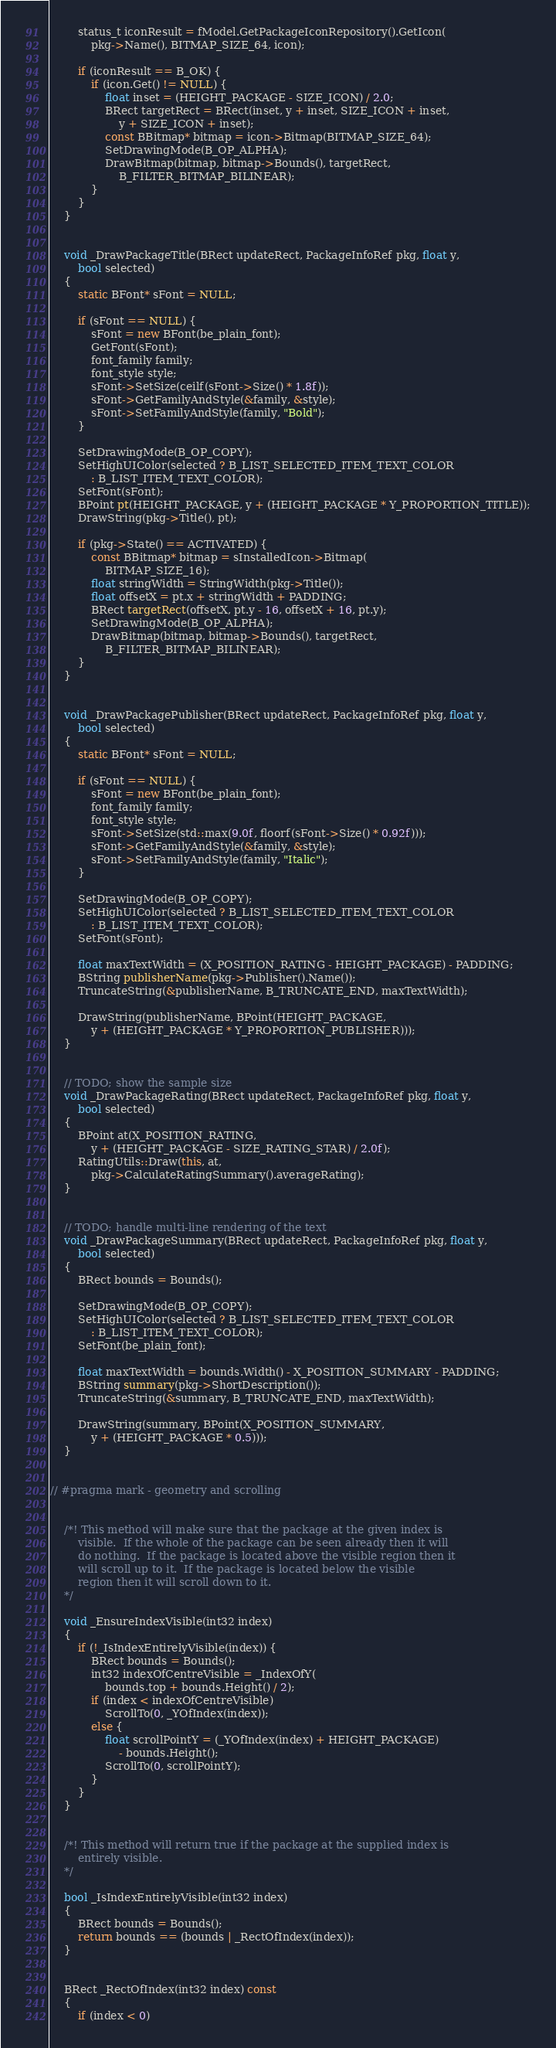Convert code to text. <code><loc_0><loc_0><loc_500><loc_500><_C++_>		status_t iconResult = fModel.GetPackageIconRepository().GetIcon(
			pkg->Name(), BITMAP_SIZE_64, icon);

		if (iconResult == B_OK) {
			if (icon.Get() != NULL) {
				float inset = (HEIGHT_PACKAGE - SIZE_ICON) / 2.0;
				BRect targetRect = BRect(inset, y + inset, SIZE_ICON + inset,
					y + SIZE_ICON + inset);
				const BBitmap* bitmap = icon->Bitmap(BITMAP_SIZE_64);
				SetDrawingMode(B_OP_ALPHA);
				DrawBitmap(bitmap, bitmap->Bounds(), targetRect,
					B_FILTER_BITMAP_BILINEAR);
			}
		}
	}


	void _DrawPackageTitle(BRect updateRect, PackageInfoRef pkg, float y,
		bool selected)
	{
		static BFont* sFont = NULL;

		if (sFont == NULL) {
			sFont = new BFont(be_plain_font);
			GetFont(sFont);
  			font_family family;
			font_style style;
			sFont->SetSize(ceilf(sFont->Size() * 1.8f));
			sFont->GetFamilyAndStyle(&family, &style);
			sFont->SetFamilyAndStyle(family, "Bold");
		}

		SetDrawingMode(B_OP_COPY);
		SetHighUIColor(selected ? B_LIST_SELECTED_ITEM_TEXT_COLOR
			: B_LIST_ITEM_TEXT_COLOR);
		SetFont(sFont);
		BPoint pt(HEIGHT_PACKAGE, y + (HEIGHT_PACKAGE * Y_PROPORTION_TITLE));
		DrawString(pkg->Title(), pt);

		if (pkg->State() == ACTIVATED) {
			const BBitmap* bitmap = sInstalledIcon->Bitmap(
				BITMAP_SIZE_16);
			float stringWidth = StringWidth(pkg->Title());
			float offsetX = pt.x + stringWidth + PADDING;
			BRect targetRect(offsetX, pt.y - 16, offsetX + 16, pt.y);
			SetDrawingMode(B_OP_ALPHA);
			DrawBitmap(bitmap, bitmap->Bounds(), targetRect,
				B_FILTER_BITMAP_BILINEAR);
		}
	}


	void _DrawPackagePublisher(BRect updateRect, PackageInfoRef pkg, float y,
		bool selected)
	{
		static BFont* sFont = NULL;

		if (sFont == NULL) {
			sFont = new BFont(be_plain_font);
			font_family family;
			font_style style;
			sFont->SetSize(std::max(9.0f, floorf(sFont->Size() * 0.92f)));
			sFont->GetFamilyAndStyle(&family, &style);
			sFont->SetFamilyAndStyle(family, "Italic");
		}

		SetDrawingMode(B_OP_COPY);
		SetHighUIColor(selected ? B_LIST_SELECTED_ITEM_TEXT_COLOR
			: B_LIST_ITEM_TEXT_COLOR);
		SetFont(sFont);

		float maxTextWidth = (X_POSITION_RATING - HEIGHT_PACKAGE) - PADDING;
		BString publisherName(pkg->Publisher().Name());
		TruncateString(&publisherName, B_TRUNCATE_END, maxTextWidth);

		DrawString(publisherName, BPoint(HEIGHT_PACKAGE,
			y + (HEIGHT_PACKAGE * Y_PROPORTION_PUBLISHER)));
	}


	// TODO; show the sample size
	void _DrawPackageRating(BRect updateRect, PackageInfoRef pkg, float y,
		bool selected)
	{
		BPoint at(X_POSITION_RATING,
			y + (HEIGHT_PACKAGE - SIZE_RATING_STAR) / 2.0f);
		RatingUtils::Draw(this, at,
			pkg->CalculateRatingSummary().averageRating);
	}


	// TODO; handle multi-line rendering of the text
	void _DrawPackageSummary(BRect updateRect, PackageInfoRef pkg, float y,
		bool selected)
	{
		BRect bounds = Bounds();

		SetDrawingMode(B_OP_COPY);
		SetHighUIColor(selected ? B_LIST_SELECTED_ITEM_TEXT_COLOR
			: B_LIST_ITEM_TEXT_COLOR);
		SetFont(be_plain_font);

		float maxTextWidth = bounds.Width() - X_POSITION_SUMMARY - PADDING;
		BString summary(pkg->ShortDescription());
		TruncateString(&summary, B_TRUNCATE_END, maxTextWidth);

		DrawString(summary, BPoint(X_POSITION_SUMMARY,
			y + (HEIGHT_PACKAGE * 0.5)));
	}


// #pragma mark - geometry and scrolling


	/*!	This method will make sure that the package at the given index is
		visible.  If the whole of the package can be seen already then it will
		do nothing.  If the package is located above the visible region then it
		will scroll up to it.  If the package is located below the visible
		region then it will scroll down to it.
	*/

	void _EnsureIndexVisible(int32 index)
	{
		if (!_IsIndexEntirelyVisible(index)) {
			BRect bounds = Bounds();
			int32 indexOfCentreVisible = _IndexOfY(
				bounds.top + bounds.Height() / 2);
			if (index < indexOfCentreVisible)
				ScrollTo(0, _YOfIndex(index));
			else {
				float scrollPointY = (_YOfIndex(index) + HEIGHT_PACKAGE)
					- bounds.Height();
				ScrollTo(0, scrollPointY);
			}
		}
	}


	/*!	This method will return true if the package at the supplied index is
		entirely visible.
	*/

	bool _IsIndexEntirelyVisible(int32 index)
	{
		BRect bounds = Bounds();
		return bounds == (bounds | _RectOfIndex(index));
	}


	BRect _RectOfIndex(int32 index) const
	{
		if (index < 0)</code> 